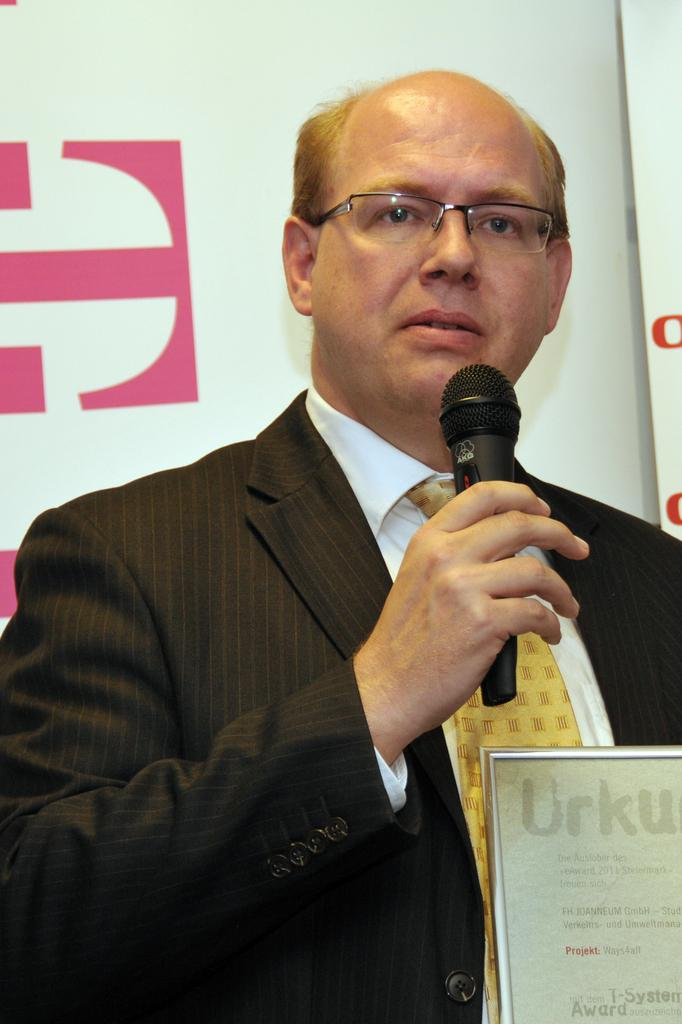What is the man in the image doing? The man is talking into a microphone. What is the man wearing in the image? The man is wearing a black blazer, a white shirt, and a tie. What can be seen in the background of the image? There is an advertisement on a wall in the background of the image. What type of knife is the boy using in the image? There is no boy or knife present in the image; it features a man talking into a microphone. What does the caption on the advertisement in the background say? The provided facts do not include information about the content of the advertisement, so we cannot determine the caption. 